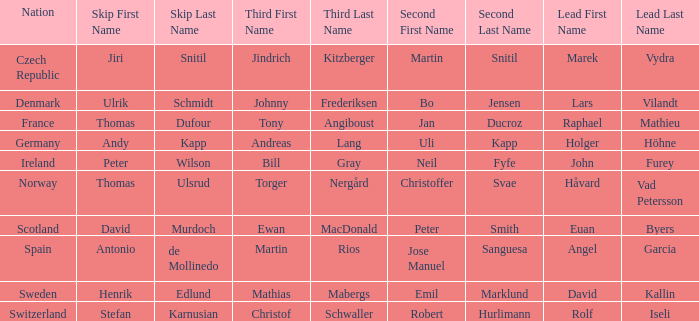When did holger höhne come in third? Andreas Lang. 